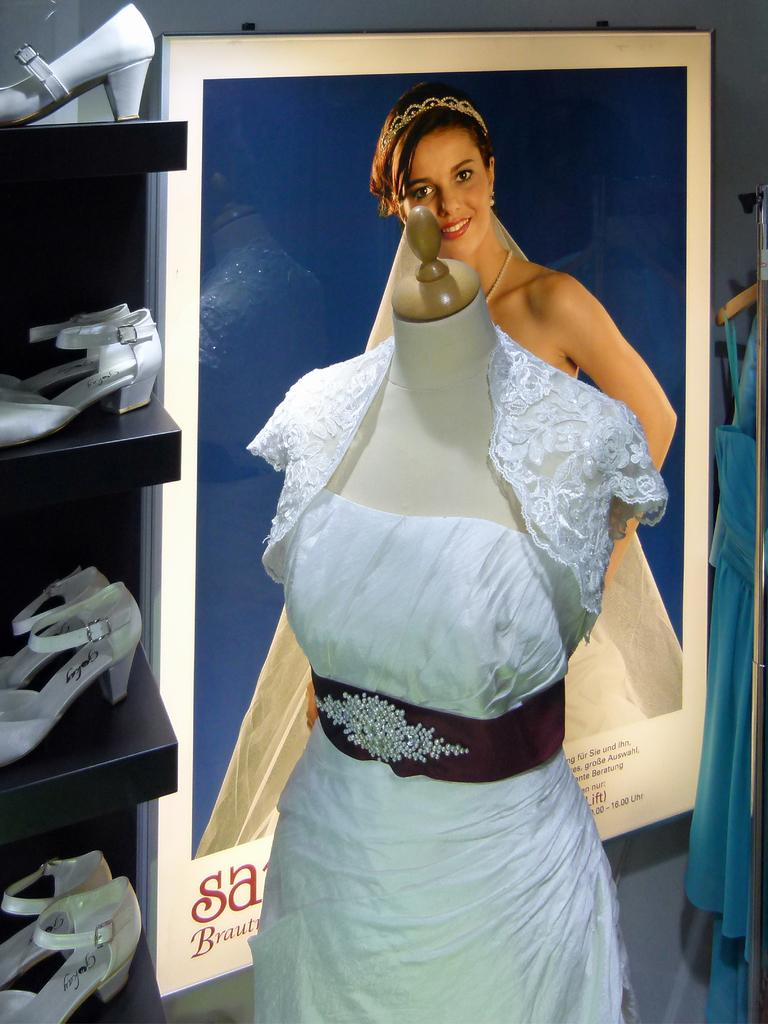What is the main subject of the image? There is a mannequin in the image. What is the mannequin wearing? The mannequin is wearing a white dress. What can be seen on the wall in the image? There is a photo frame on the wall in the image. What is present on the shelf in the image? The shelf contains white footwear. Where is the jar of toothpaste located in the image? There is no jar of toothpaste present in the image. What type of book can be seen on the shelf in the image? There are no books present in the image; the shelf contains white footwear. 